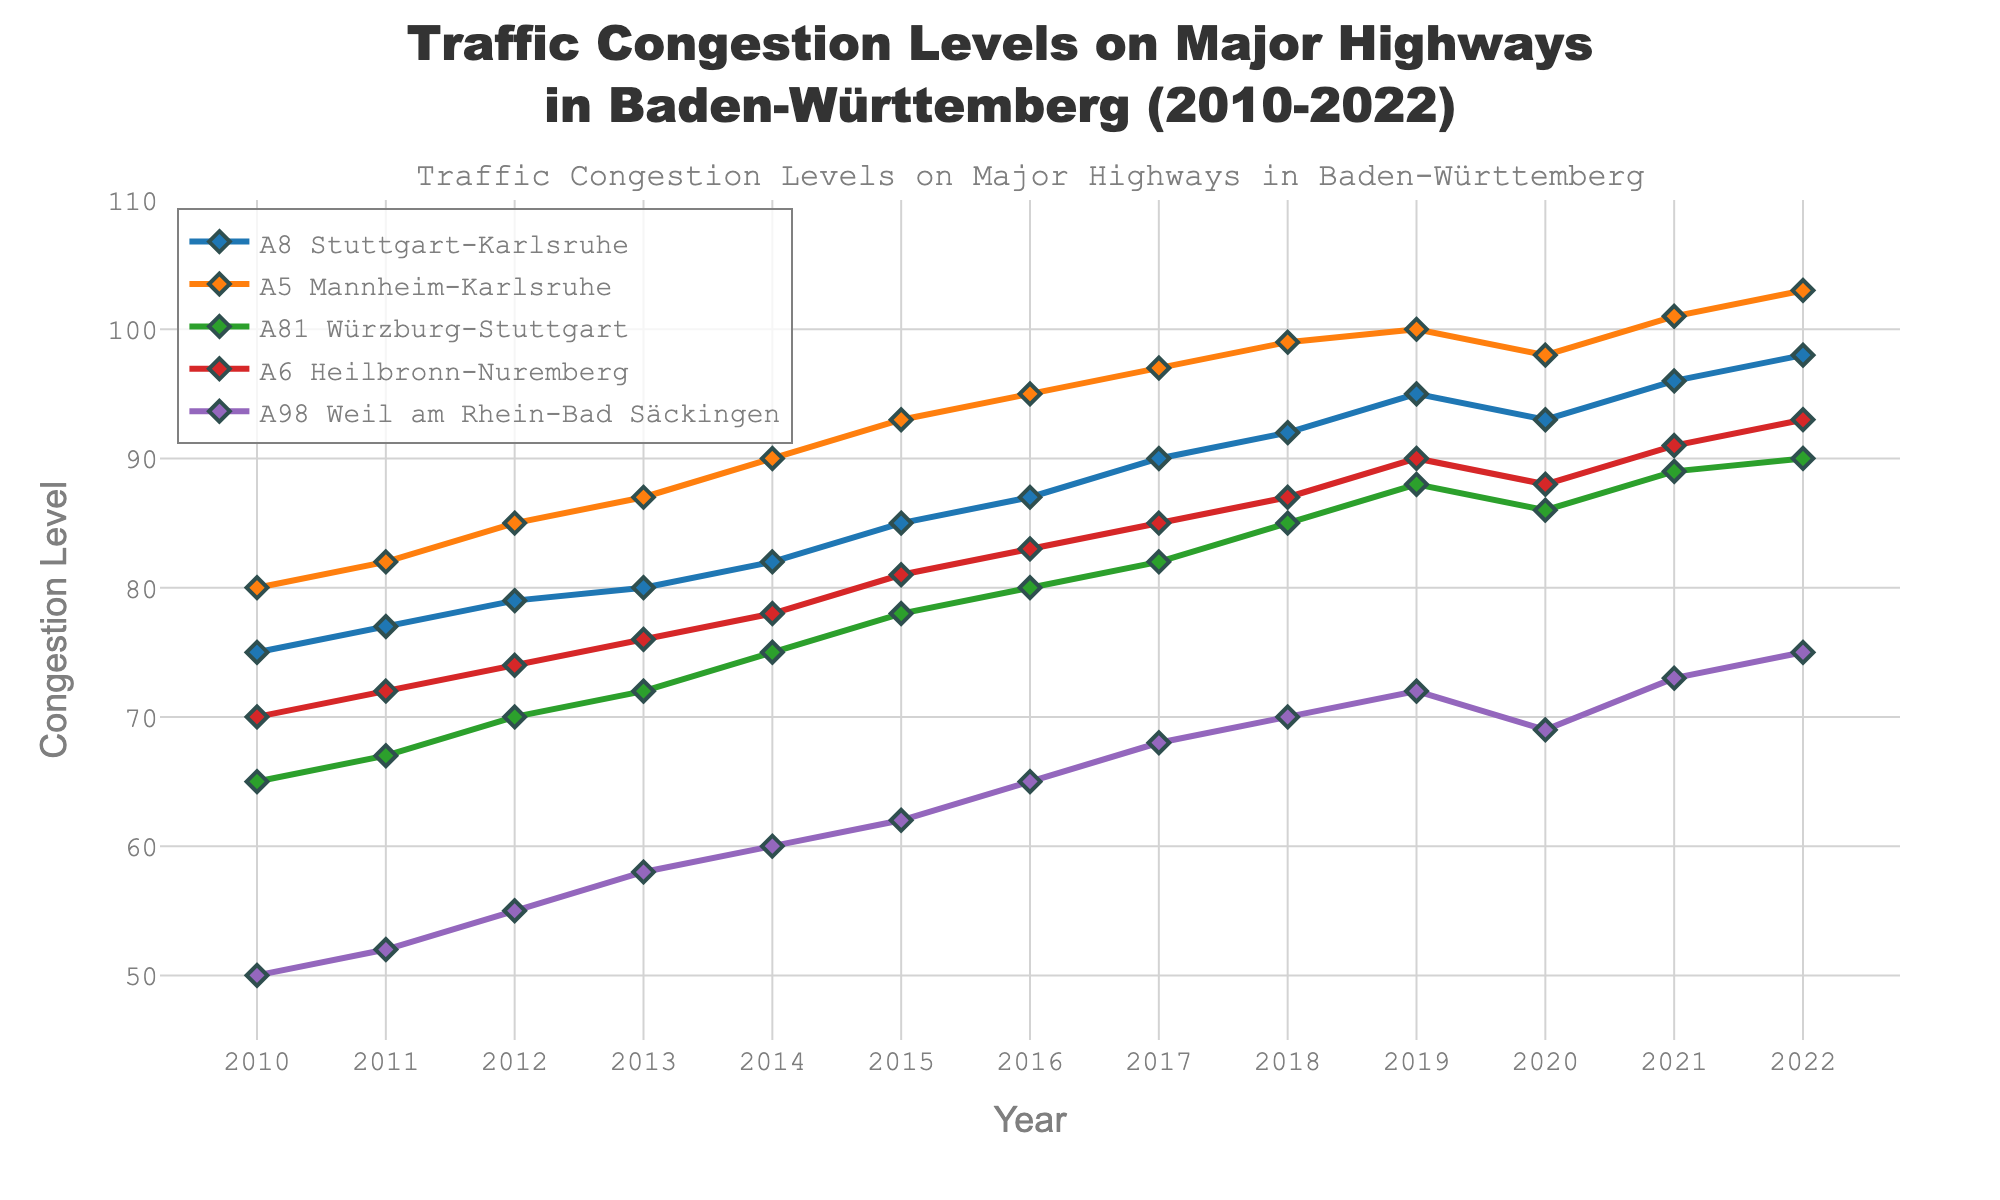What is the title of the plot? The title is typically located at the top of the plot and gives an overview of the plot's subject. In this case, the title describes the figure's purpose.
Answer: Traffic Congestion Levels on Major Highways in Baden-Württemberg (2010-2022) How many highways are being analyzed in the plot? Count the distinct lines in the plot, each representing a highway. We can identify them by different colors and legends.
Answer: Five Which highway had the highest congestion level in 2022? Look at the data points for the year 2022 and identify the highway with the highest value.
Answer: A5 Mannheim-Karlsruhe In which year did the A8 Stuttgart-Karlsruhe highway experience the highest congestion level? Follow the line representing the A8 Stuttgart-Karlsruhe highway and identify the year with the peak value.
Answer: 2022 What was the congestion level of A81 Würzburg-Stuttgart in 2015? Locate the intersection of the A81 Würzburg-Stuttgart line with the year 2015 on the x-axis and read the corresponding y-axis value.
Answer: 78 Between which years did the A98 Weil am Rhein-Bad Säckingen experience the greatest increase in congestion levels? Identify the years with the largest difference between the y-axis values for the A98 Weil am Rhein-Bad Säckingen line.
Answer: 2010 to 2011 (or 2021 to 2022 with a 2-point increase, both years show an equal highest increase) Which highway showed the least change in congestion levels from 2010 to 2022? Compare the start and end points of each highway's line and calculate the difference. The smallest difference indicates the least change.
Answer: A98 Weil am Rhein-Bad Säckingen What is the average congestion level of A6 Heilbronn-Nuremberg over the displayed years? Sum the congestion levels for A6 Heilbronn-Nuremberg over all years and divide by the total number of years (13).
Answer: (70 + 72 + 74 + 76 + 78 + 81 + 83 + 85 + 87 + 90 + 88 + 91 + 93) / 13 = 81 Which highways had a dip in congestion level in 2020 compared to 2019? Compare the 2019 and 2020 congestion levels for each highway and identify the ones that decreased.
Answer: A8 Stuttgart-Karlsruhe, A5 Mannheim-Karlsruhe, A81 Würzburg-Stuttgart, A98 Weil am Rhein-Bad Säckingen What is the trend observed in the A6 Heilbronn-Nuremberg highway from 2010 to 2022? Observe the direction and changes in the y-values of the A6 Heilbronn-Nuremberg line from 2010 to 2022 to describe whether it is increasing, decreasing, or stable.
Answer: Increasing 